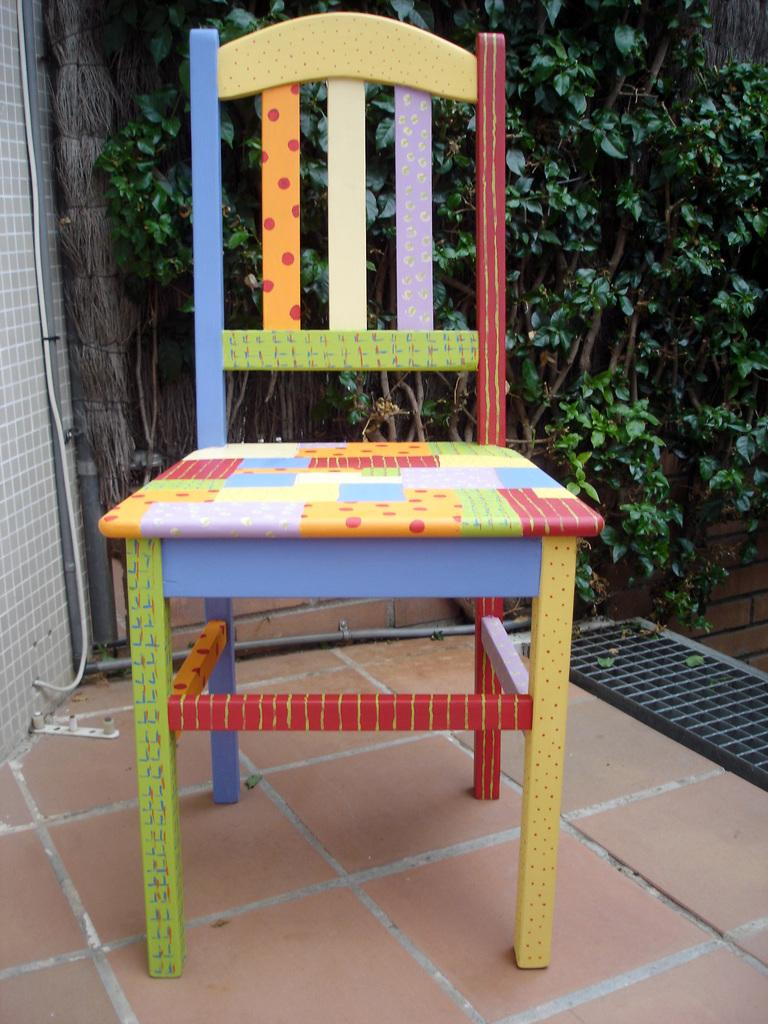What type of furniture is on the ground in the image? There is a chair on the ground in the image. What can be seen in the background of the image? There is a wall, pipes, plants, and a mesh visible in the background of the image. What color is the rhythm in the image? There is no rhythm present in the image, as it is a visual medium. 